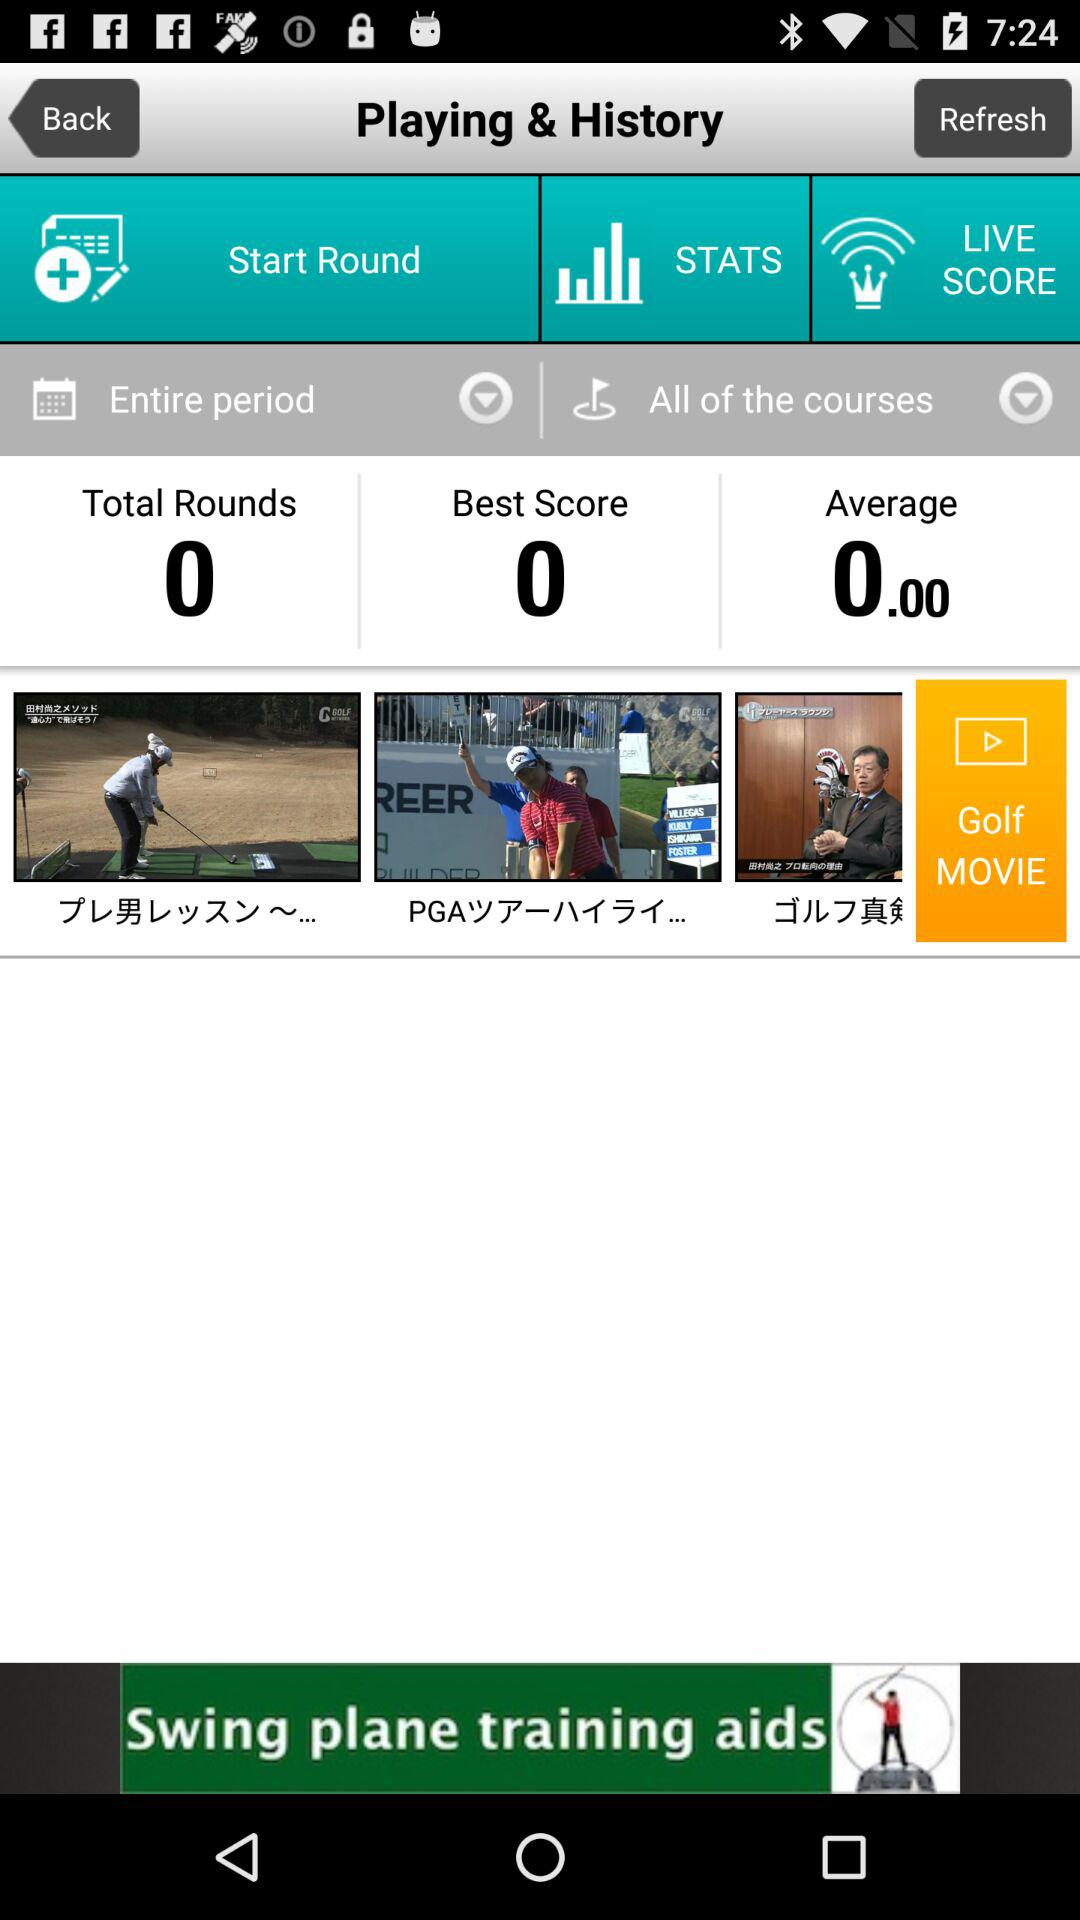What is the average? The average is 0. 